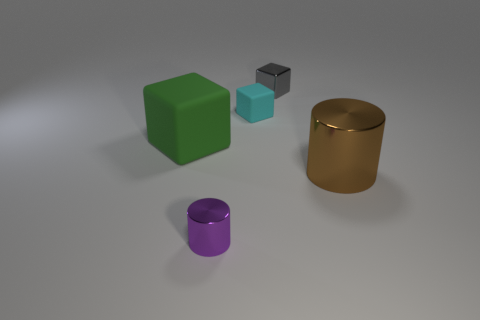Could you describe the texture and material of the green object in the image? The green object has a solid, matte texture indicative of a plastic or painted wood surface. Its blocky shape and even coloring suggest it is likely a lightweight material. 